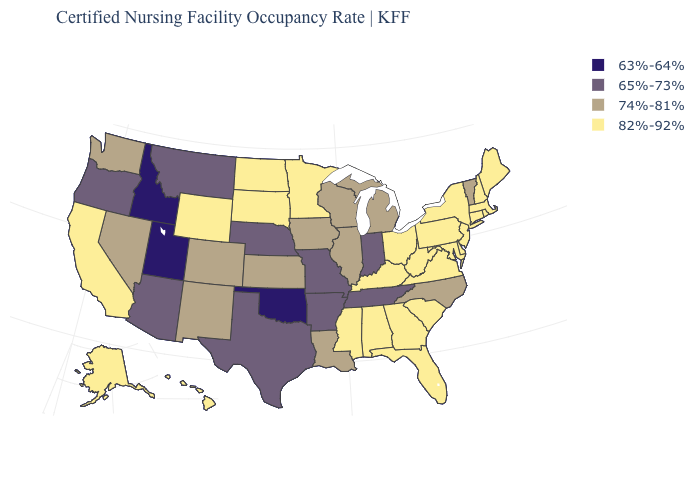What is the value of South Carolina?
Give a very brief answer. 82%-92%. How many symbols are there in the legend?
Concise answer only. 4. What is the lowest value in the USA?
Be succinct. 63%-64%. Among the states that border Iowa , which have the highest value?
Give a very brief answer. Minnesota, South Dakota. What is the value of Kentucky?
Short answer required. 82%-92%. Name the states that have a value in the range 65%-73%?
Answer briefly. Arizona, Arkansas, Indiana, Missouri, Montana, Nebraska, Oregon, Tennessee, Texas. What is the value of Oklahoma?
Concise answer only. 63%-64%. Name the states that have a value in the range 82%-92%?
Quick response, please. Alabama, Alaska, California, Connecticut, Delaware, Florida, Georgia, Hawaii, Kentucky, Maine, Maryland, Massachusetts, Minnesota, Mississippi, New Hampshire, New Jersey, New York, North Dakota, Ohio, Pennsylvania, Rhode Island, South Carolina, South Dakota, Virginia, West Virginia, Wyoming. What is the highest value in the MidWest ?
Quick response, please. 82%-92%. Does Nebraska have the highest value in the USA?
Keep it brief. No. How many symbols are there in the legend?
Be succinct. 4. What is the value of Mississippi?
Give a very brief answer. 82%-92%. What is the value of Oregon?
Short answer required. 65%-73%. What is the value of New Jersey?
Be succinct. 82%-92%. 